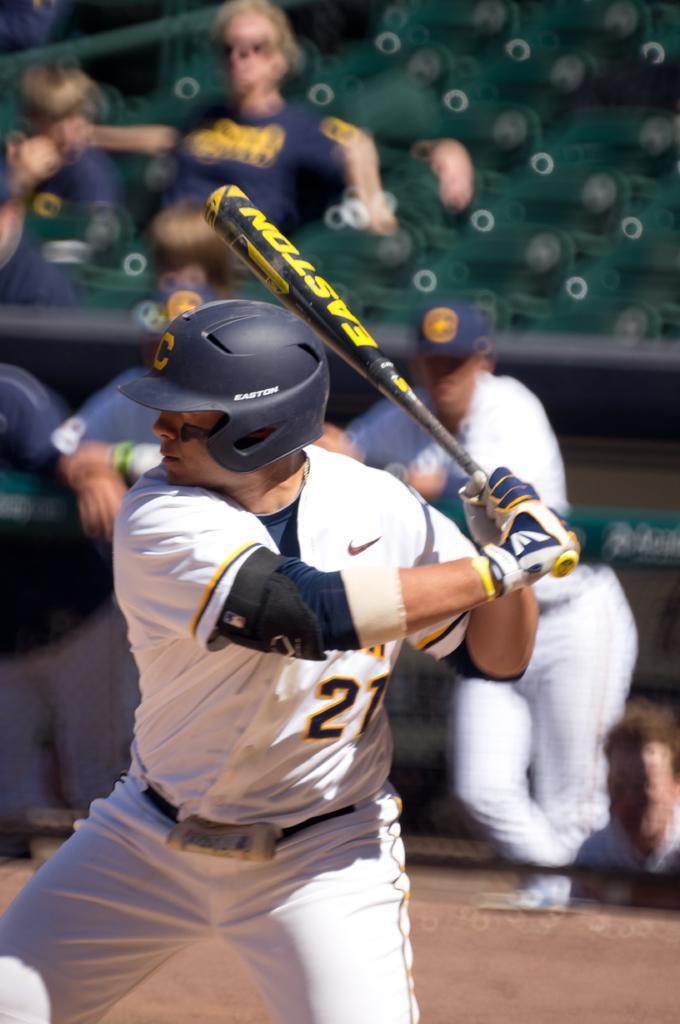Please provide a concise description of this image. In this picture, we can see a few people, and among them a person with helmet and holding an object is highlighted, we can see ground, blurred background. 